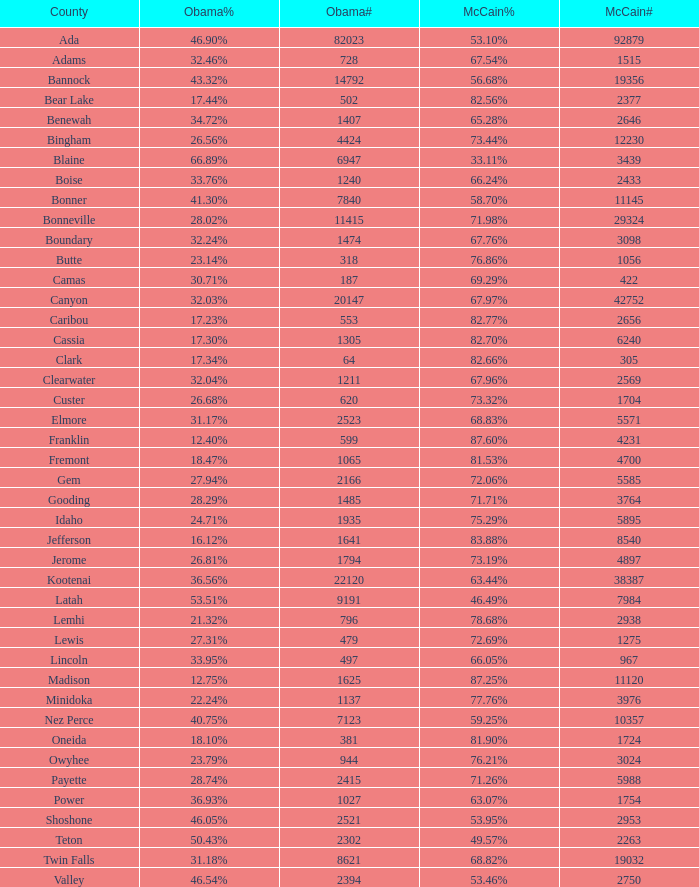What is the McCain vote percentage in Jerome county? 73.19%. 